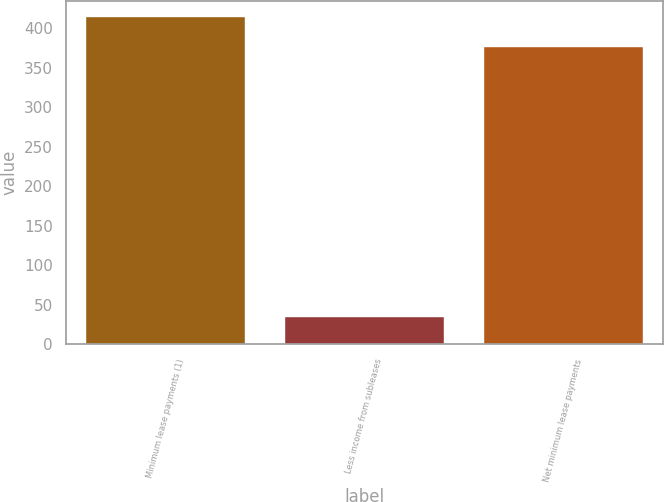<chart> <loc_0><loc_0><loc_500><loc_500><bar_chart><fcel>Minimum lease payments (1)<fcel>Less income from subleases<fcel>Net minimum lease payments<nl><fcel>413.71<fcel>35.2<fcel>376.1<nl></chart> 